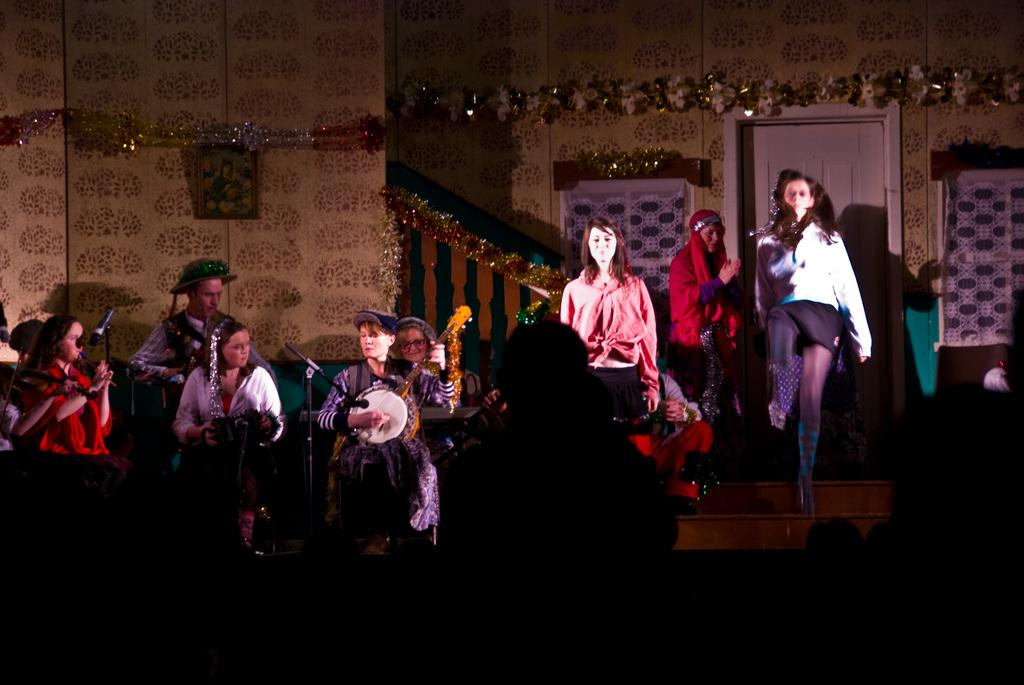What is hanging on the wall in the image? There is a picture on the wall in the image. What else can be seen on the wall besides the picture? There are decorative ribbons on the wall. What architectural features are present in the image? There is a door and windows in the image. What are the people in the image doing? The people are standing in front of the door and windows, and they are playing musical instruments. What object is present in front of the people? There is a microphone (mic) in front of the people. What type of relation is depicted between the people in the image? There is no specific relation depicted between the people in the image; they are simply playing musical instruments together. How much debt is owed by the people in the image? There is no information about debt in the image; it focuses on the people playing musical instruments and the presence of a microphone. 